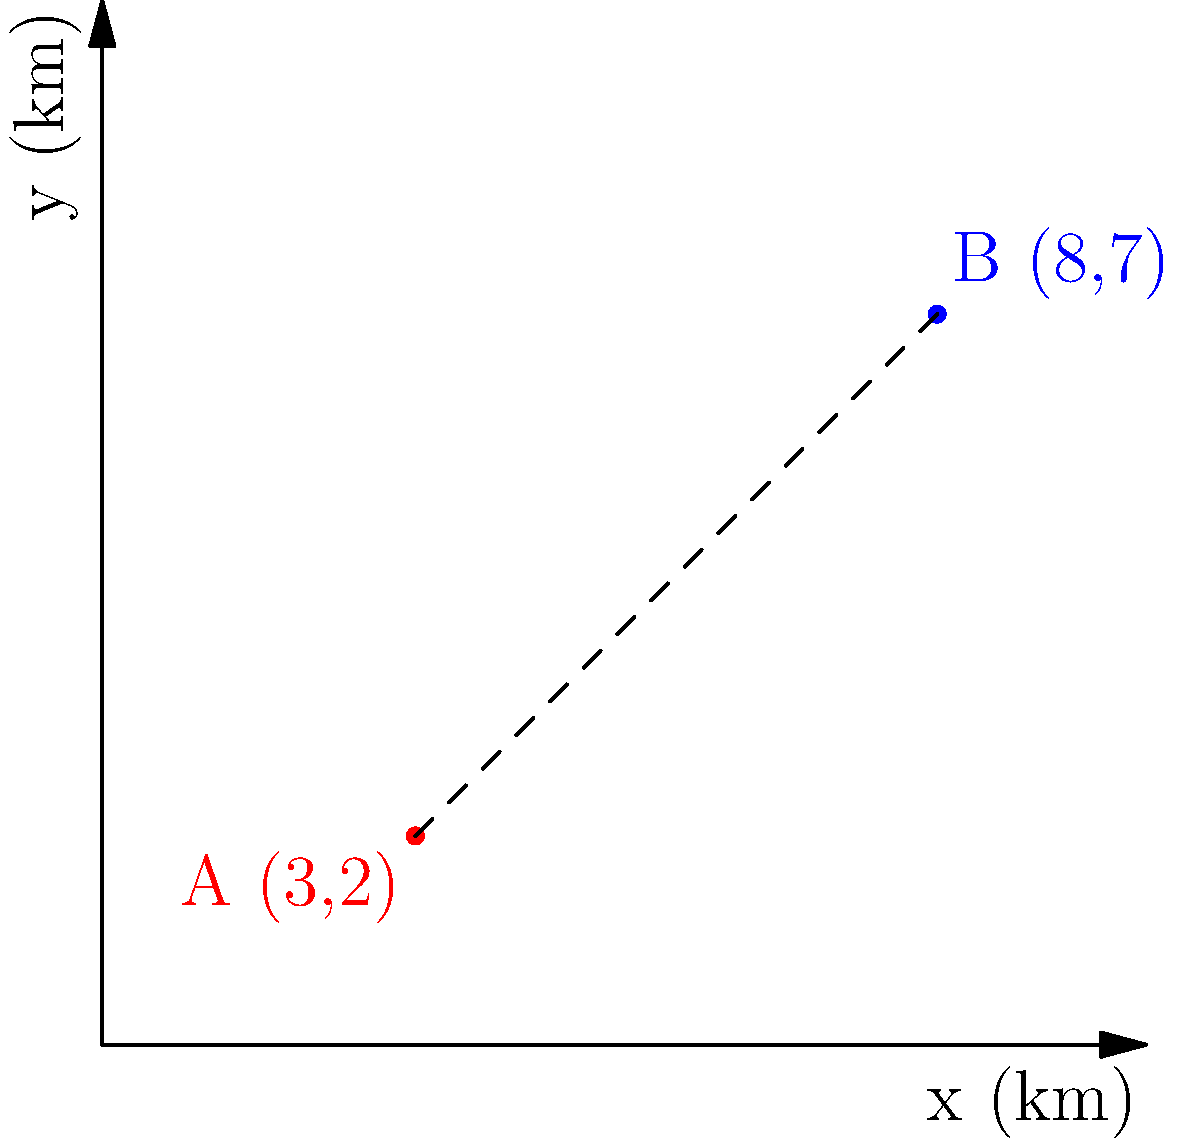In a luxury complex in Pune, two high-rise buildings are located at coordinates A(3,2) and B(8,7) on a city map, where each unit represents 1 km. What is the straight-line distance between these two buildings? To find the distance between two points on a coordinate plane, we can use the distance formula:

$$d = \sqrt{(x_2 - x_1)^2 + (y_2 - y_1)^2}$$

Where $(x_1, y_1)$ are the coordinates of the first point and $(x_2, y_2)$ are the coordinates of the second point.

Given:
Point A: $(x_1, y_1) = (3, 2)$
Point B: $(x_2, y_2) = (8, 7)$

Let's substitute these values into the formula:

$$d = \sqrt{(8 - 3)^2 + (7 - 2)^2}$$

Now, let's solve step by step:

1) First, calculate the differences:
   $$d = \sqrt{(5)^2 + (5)^2}$$

2) Square the differences:
   $$d = \sqrt{25 + 25}$$

3) Add the squared differences:
   $$d = \sqrt{50}$$

4) Simplify the square root:
   $$d = 5\sqrt{2}$$

5) To get a decimal approximation:
   $$d \approx 7.07 \text{ km}$$

Therefore, the straight-line distance between the two high-rise buildings is $5\sqrt{2}$ km or approximately 7.07 km.
Answer: $5\sqrt{2}$ km 